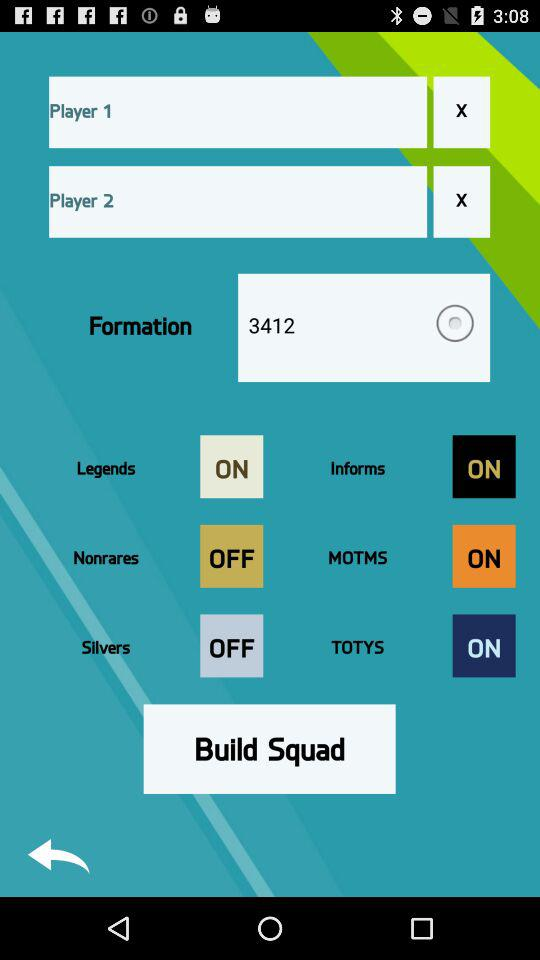What is the status of "Silvers"? The status of "Silvers" is "off". 